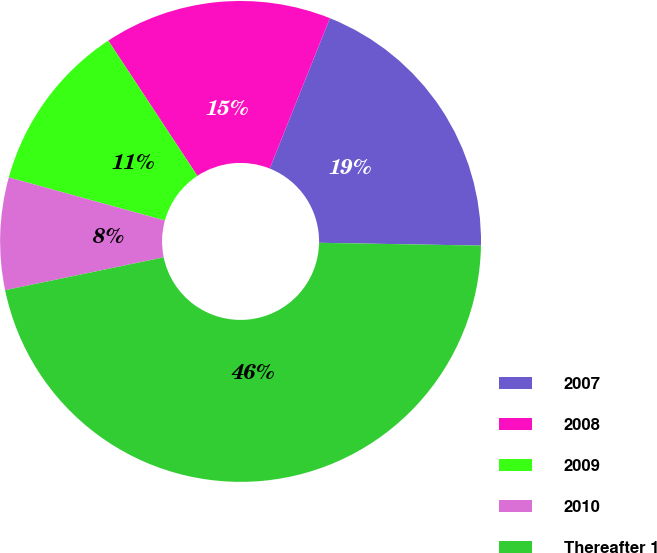<chart> <loc_0><loc_0><loc_500><loc_500><pie_chart><fcel>2007<fcel>2008<fcel>2009<fcel>2010<fcel>Thereafter 1<nl><fcel>19.22%<fcel>15.33%<fcel>11.44%<fcel>7.54%<fcel>46.47%<nl></chart> 